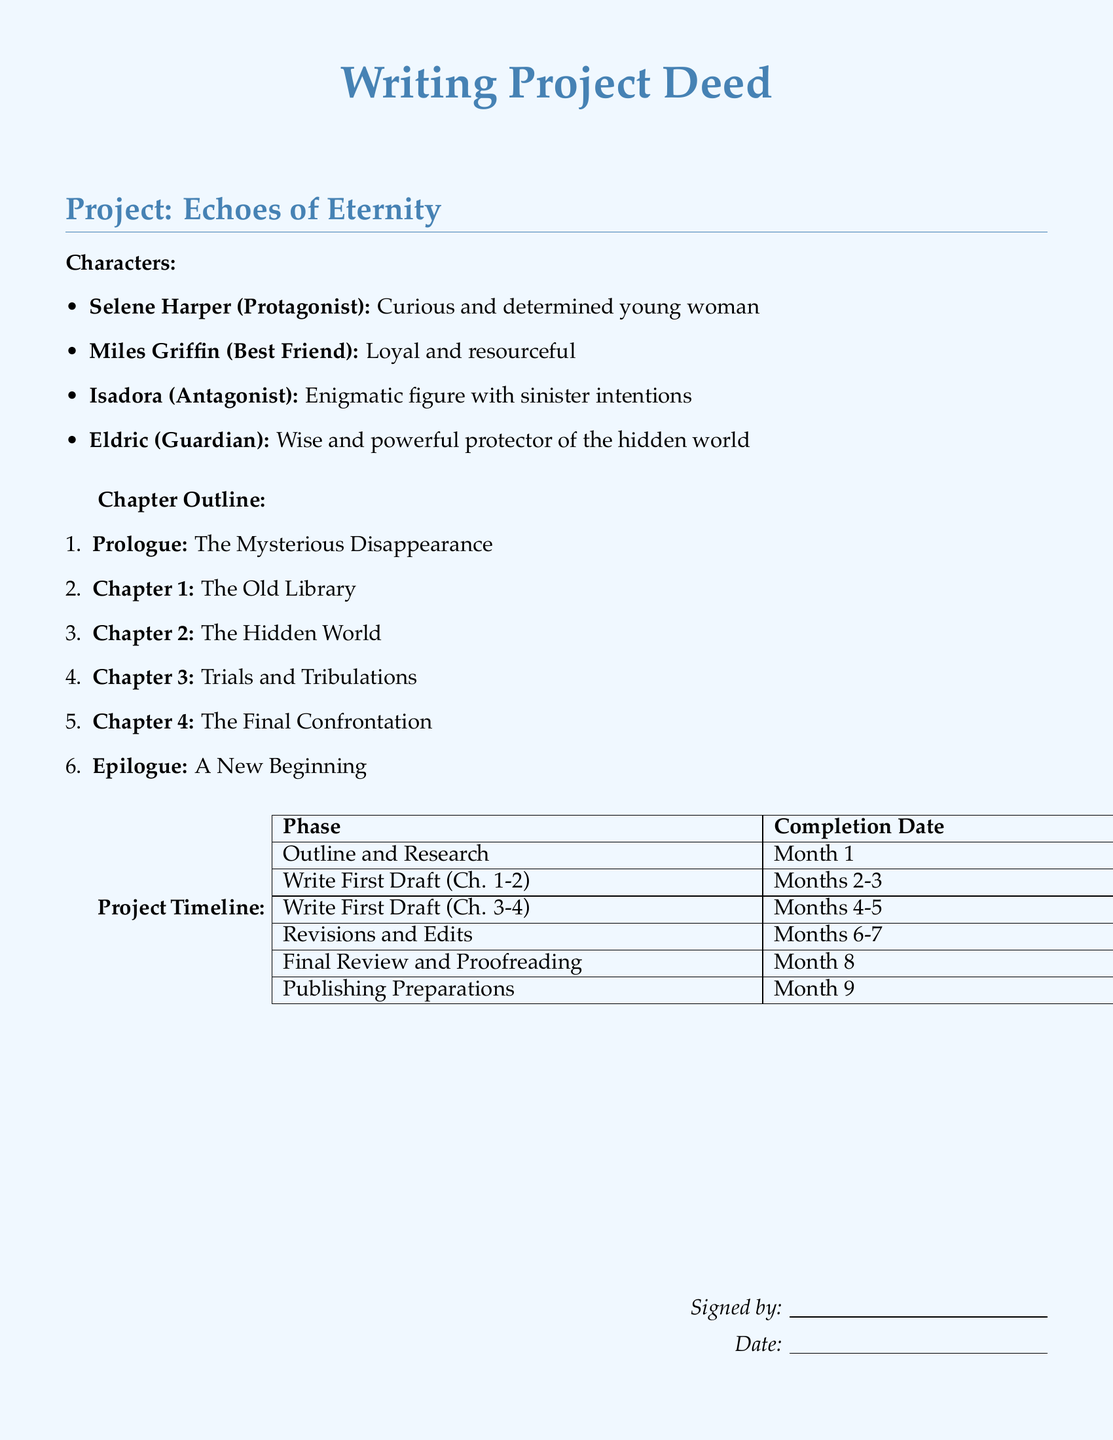What is the title of the project? The title is stated prominently at the beginning of the document, as "Writing Project Deed" under the project name.
Answer: Echoes of Eternity Who is the protagonist of the story? The protagonist is defined in the character outline before the chapter list, making it easy to identify.
Answer: Selene Harper How many main characters are listed in the document? The number of characters can be counted directly from the character outline section of the document.
Answer: 4 What is the final phase in the project timeline? The last entry in the timeline table indicates the final phase of the project.
Answer: Publishing Preparations In which month is the first draft of Chapters 3 and 4 scheduled to be written? The timeline provides specific months for each phase, including details about the episodes being drafted.
Answer: Months 4-5 What significant event occurs in the prologue? The prologue captures the first major plot point to be addressed.
Answer: The Mysterious Disappearance Who is the antagonist of the story? The antagonist is specifically listed in the character outline section of the document.
Answer: Isadora What is the main theme implied by the title "Echoes of Eternity"? The project title suggests a thematic exploration based on the concept presented in the title itself.
Answer: (Subject to interpretation based on text) How long is the entire project timeline projected to take? The timeline specifies individual phases, which can be summed to determine the overall project length.
Answer: 9 months 